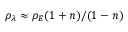Convert formula to latex. <formula><loc_0><loc_0><loc_500><loc_500>\rho _ { \lambda } \approx \rho _ { E } ( 1 + n ) / ( 1 - n )</formula> 